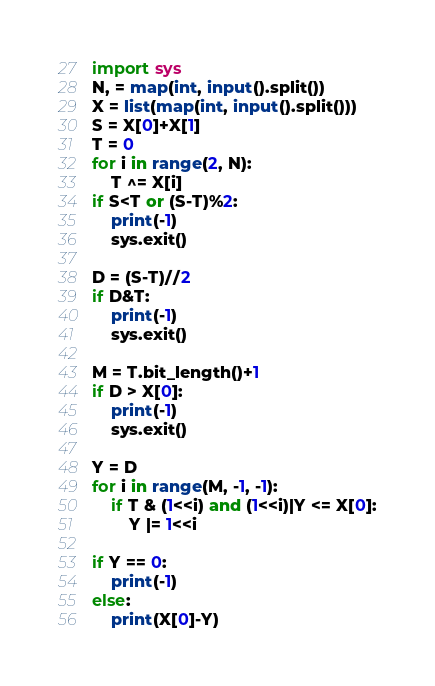Convert code to text. <code><loc_0><loc_0><loc_500><loc_500><_Python_>import sys
N, = map(int, input().split())
X = list(map(int, input().split()))
S = X[0]+X[1]
T = 0
for i in range(2, N):
    T ^= X[i]
if S<T or (S-T)%2:
    print(-1)
    sys.exit()

D = (S-T)//2
if D&T:
    print(-1)
    sys.exit()

M = T.bit_length()+1
if D > X[0]:
    print(-1)
    sys.exit()

Y = D
for i in range(M, -1, -1):
    if T & (1<<i) and (1<<i)|Y <= X[0]:
        Y |= 1<<i

if Y == 0:
    print(-1)
else:
    print(X[0]-Y)
</code> 